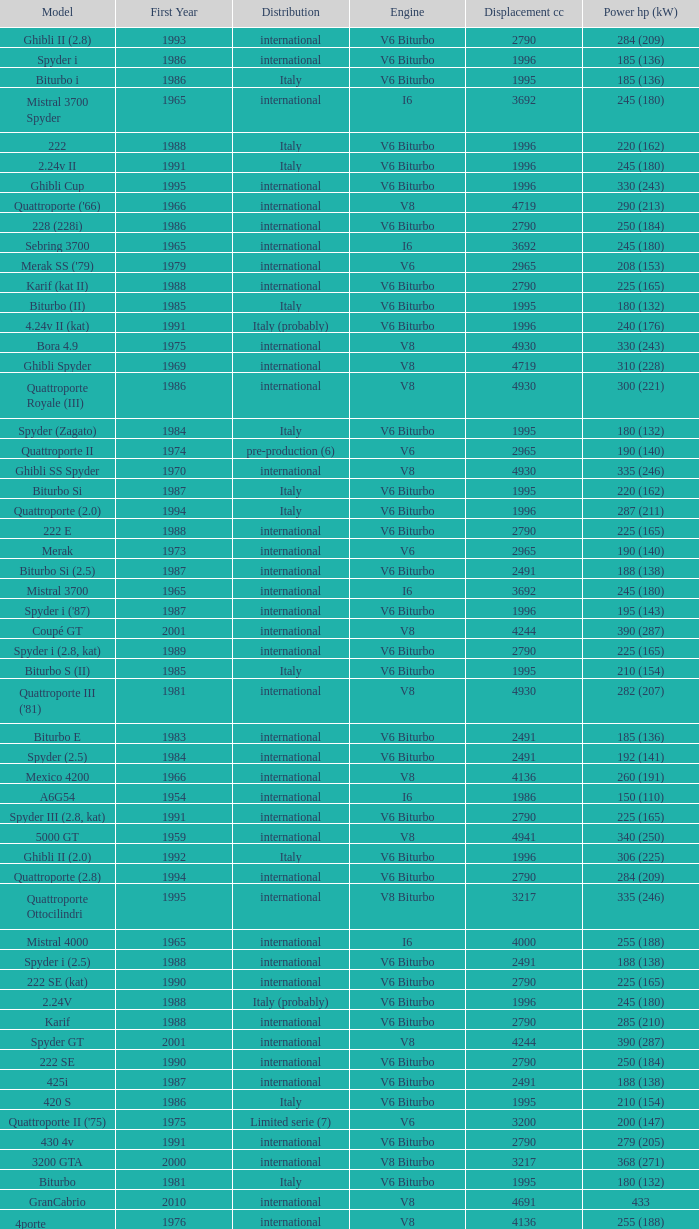What is the lowest First Year, when Model is "Quattroporte (2.8)"? 1994.0. 